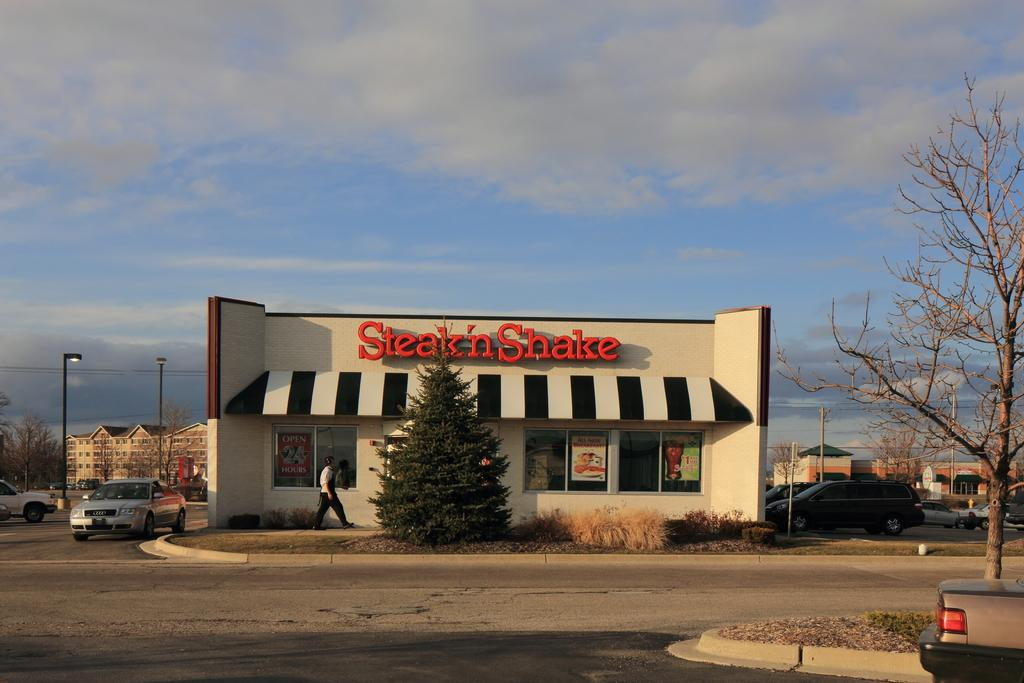What types of structures are visible in the image? There are buildings in the image. What else can be seen in the image besides buildings? There are vehicles, trees, posters, lights, wires, and poles visible in the image. Can you describe the person in the image? There is a person in the image. What is visible in the background of the image? The sky is visible in the background of the image, and there are clouds in the sky. How many clocks are hanging on the buildings in the image? There is no mention of clocks in the image, so it is impossible to determine how many are present. Is the image set during the night? The presence of clouds in the sky suggests that it is daytime, not nighttime, in the image. 